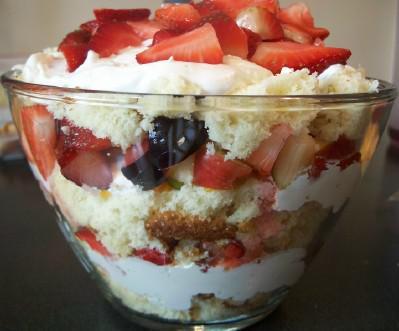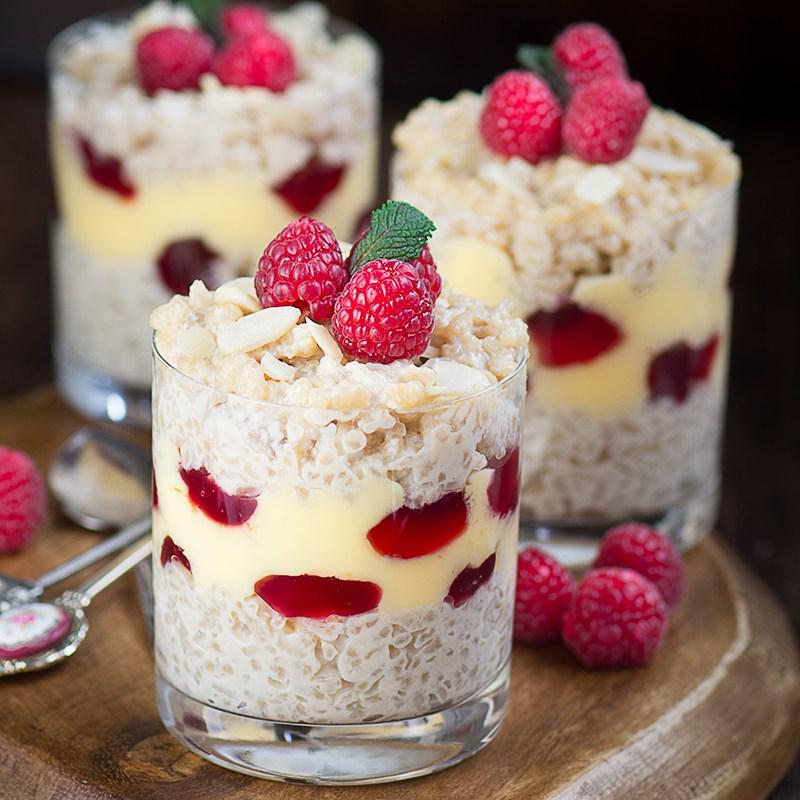The first image is the image on the left, the second image is the image on the right. Given the left and right images, does the statement "One of the images contains exactly two dessert filled containers." hold true? Answer yes or no. No. 